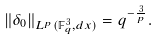Convert formula to latex. <formula><loc_0><loc_0><loc_500><loc_500>\| \delta _ { 0 } \| _ { L ^ { p } ( \mathbb { F } _ { q } ^ { 3 } , d x ) } = q ^ { - \frac { 3 } { p } } .</formula> 